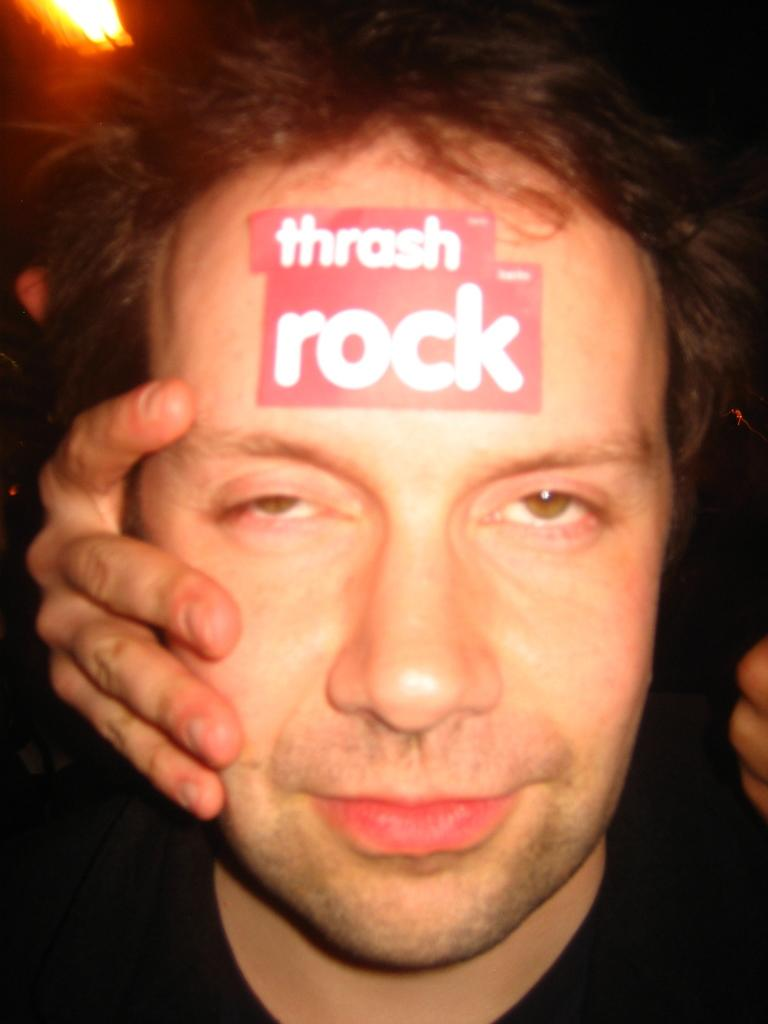What is the main subject of the image? There is a man in the image. Can you describe the man's appearance in the image? The man has a sticker over his hand. What is the person next to the man doing in the image? There is a person holding their head in the image. Where is the light source located in the image? There is a light on the left side of the image. What type of zinc is the man using to read in the image? There is no zinc or reading activity present in the image. How much of the bit is visible in the image? There is no bit present in the image. 